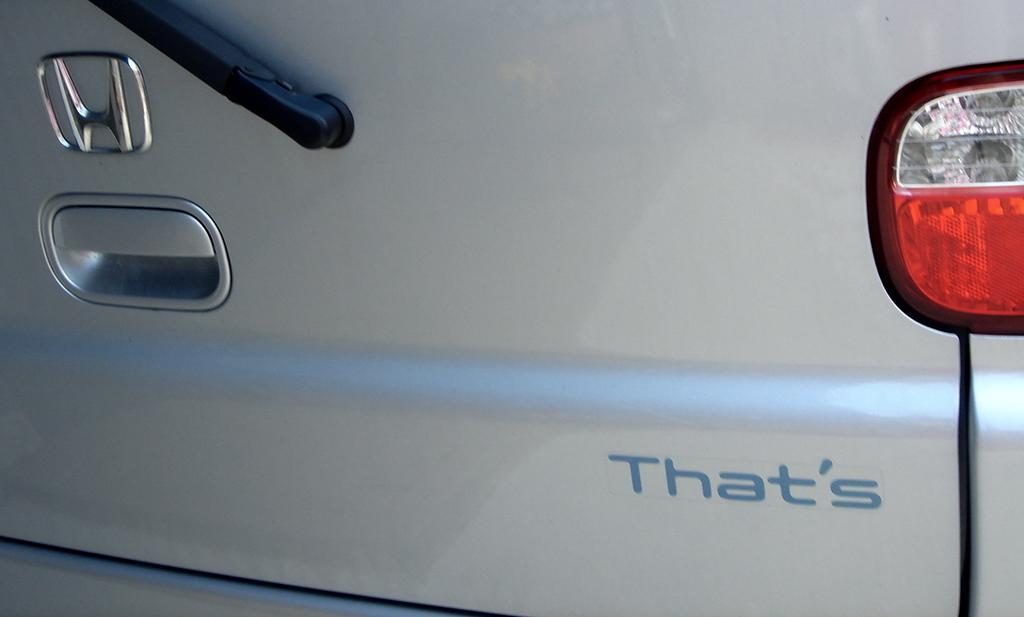Could you give a brief overview of what you see in this image? In the image there is a car back door with logo, handle and light. There is something written on the door. 